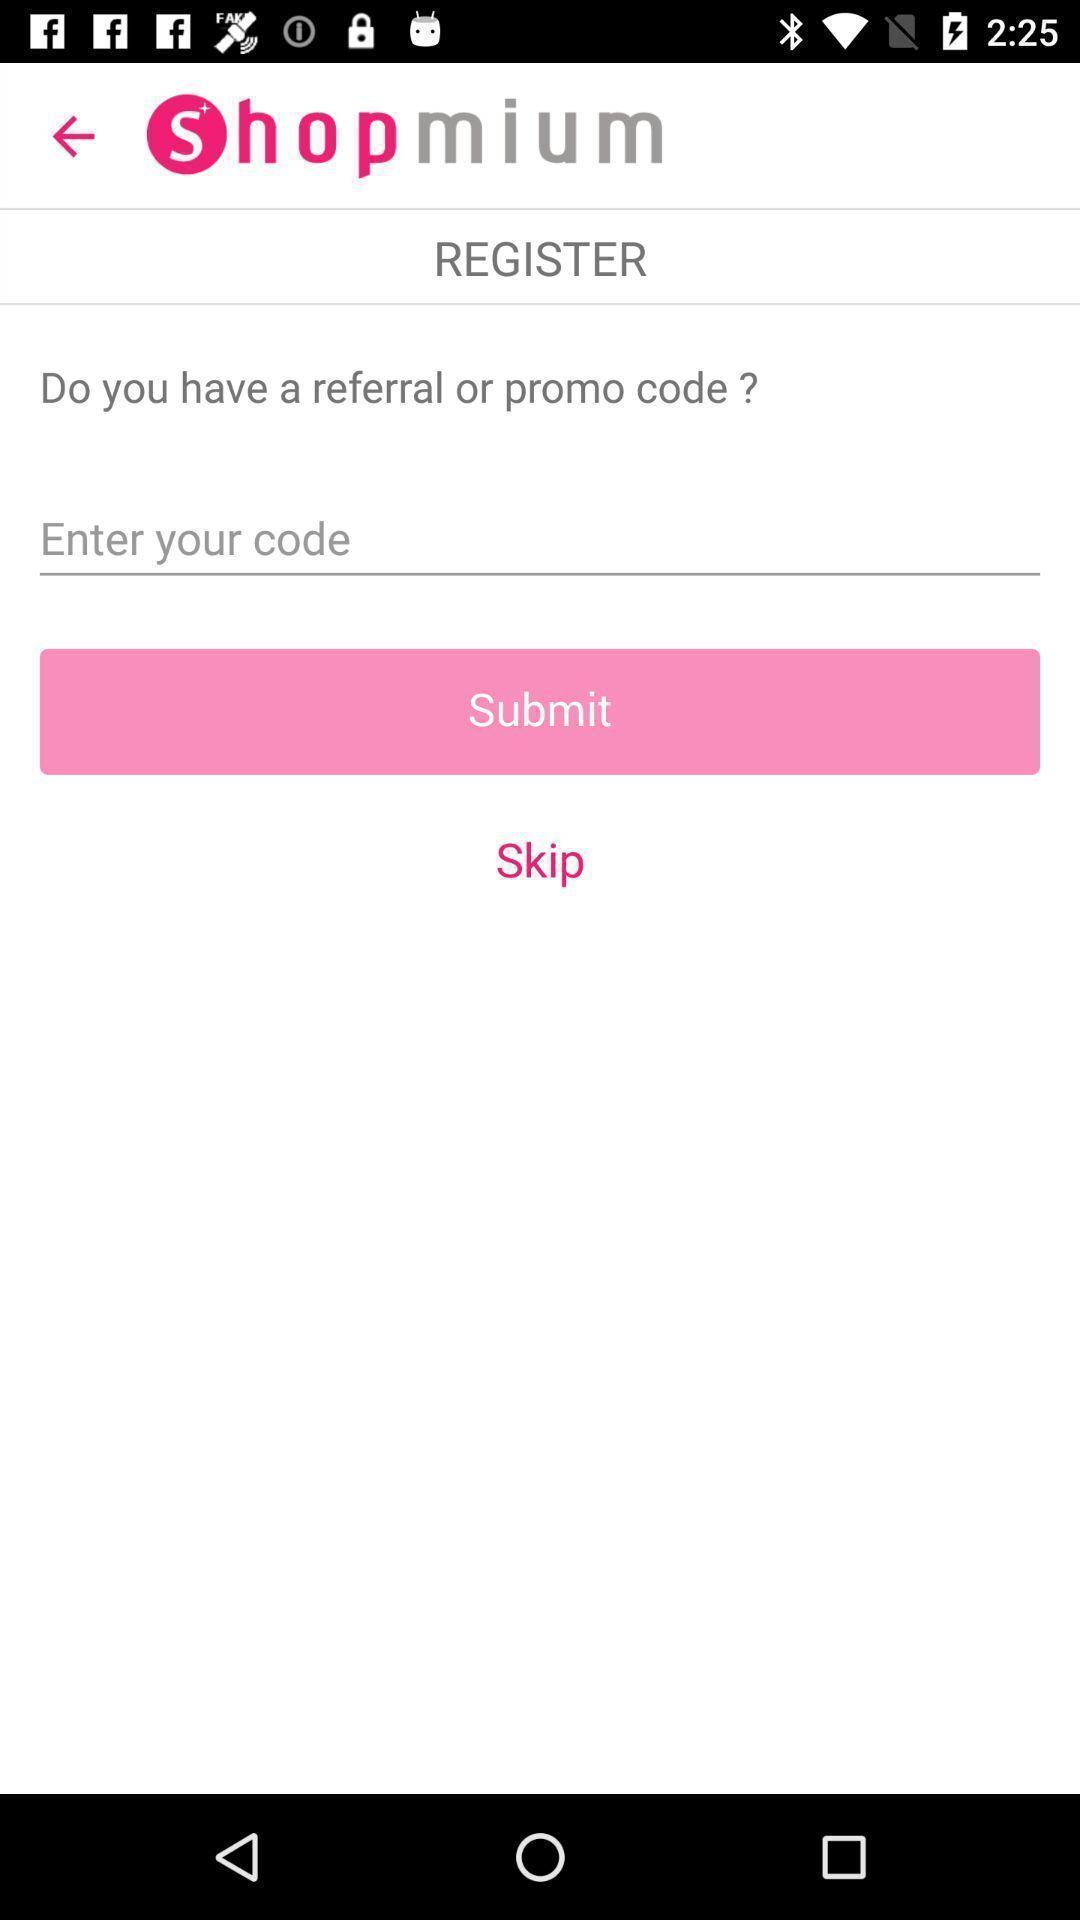Describe the key features of this screenshot. Resgister page for a shopping app. 